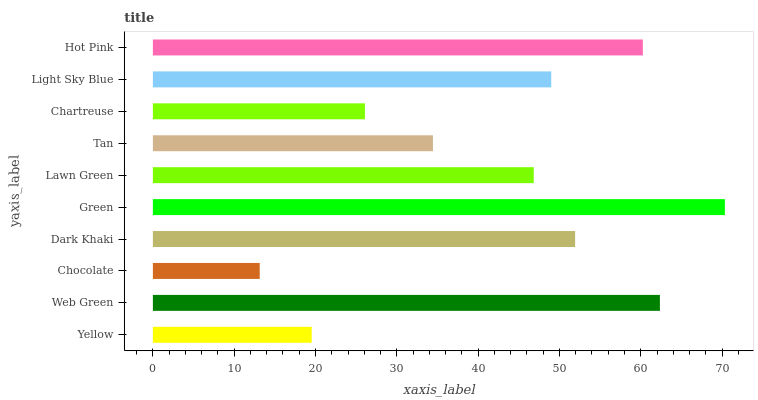Is Chocolate the minimum?
Answer yes or no. Yes. Is Green the maximum?
Answer yes or no. Yes. Is Web Green the minimum?
Answer yes or no. No. Is Web Green the maximum?
Answer yes or no. No. Is Web Green greater than Yellow?
Answer yes or no. Yes. Is Yellow less than Web Green?
Answer yes or no. Yes. Is Yellow greater than Web Green?
Answer yes or no. No. Is Web Green less than Yellow?
Answer yes or no. No. Is Light Sky Blue the high median?
Answer yes or no. Yes. Is Lawn Green the low median?
Answer yes or no. Yes. Is Web Green the high median?
Answer yes or no. No. Is Chocolate the low median?
Answer yes or no. No. 